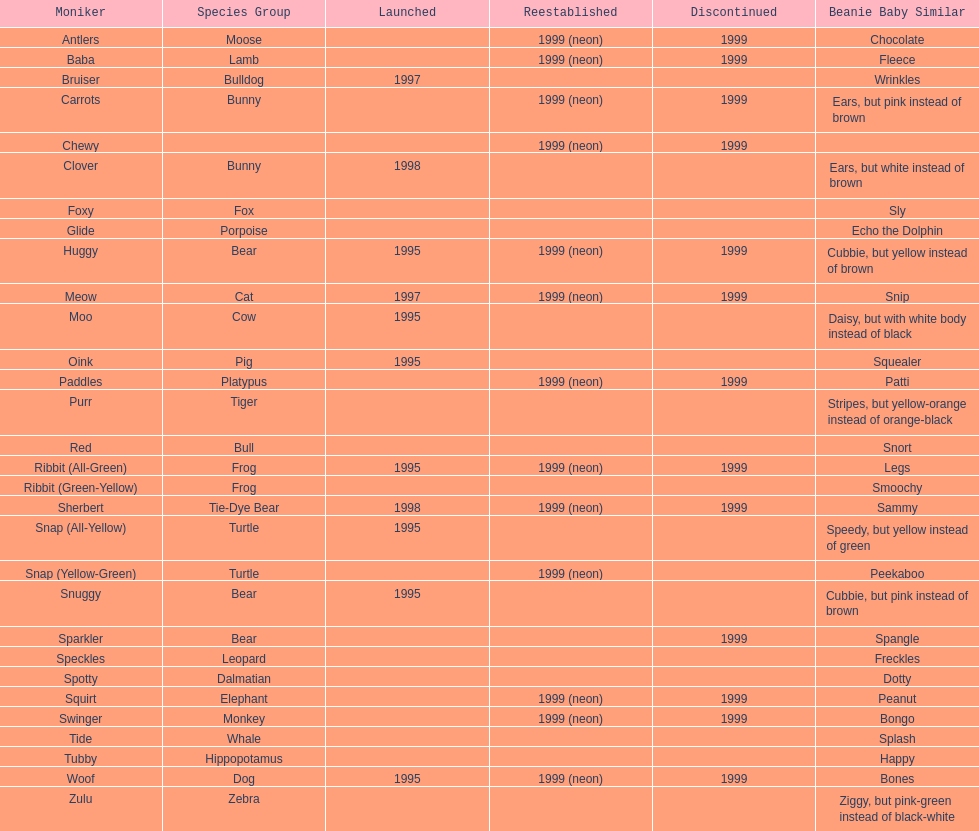What is the number of frog pillow pals? 2. 